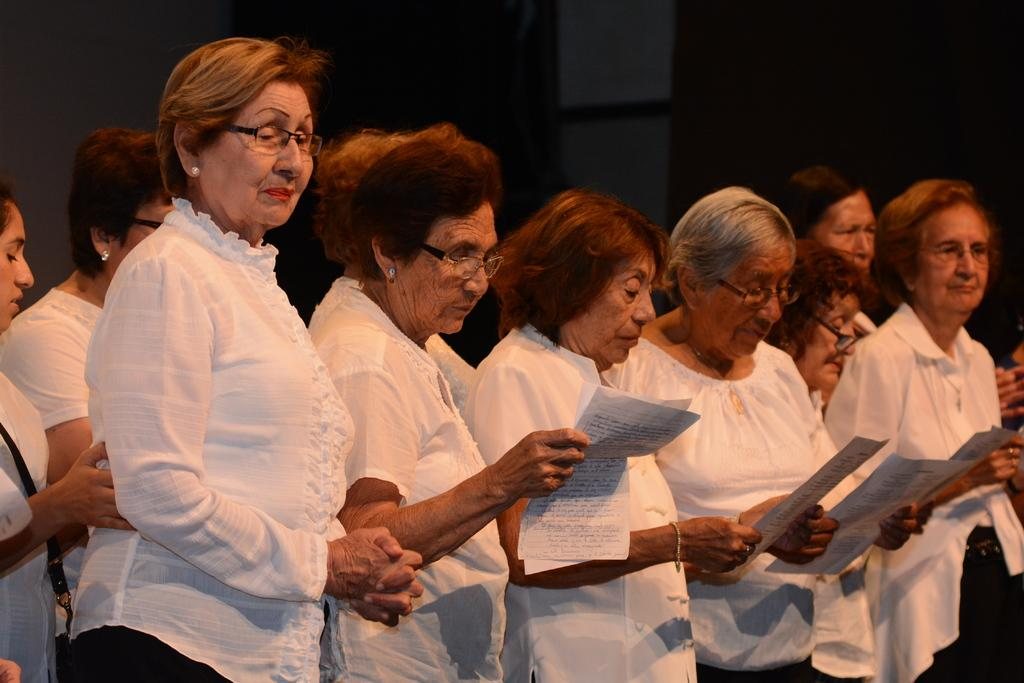How many people are in the image? There are persons standing in the image. What are some of the people holding in their hands? Some of the persons are holding papers in their hands. What can be observed about the lighting in the image? The background of the image is dark. What else can be seen in the background of the image? Objects are visible in the background of the image. How many houses are visible in the image? There are no houses visible in the image; it only features persons standing and holding papers. What type of feeling can be seen on the faces of the people in the image? The image does not provide information about the feelings or expressions of the people; only their actions of standing and holding papers are visible. 